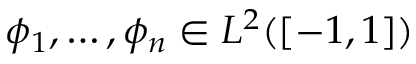Convert formula to latex. <formula><loc_0><loc_0><loc_500><loc_500>\phi _ { 1 } , \dots , \phi _ { n } \in L ^ { 2 } ( [ - 1 , 1 ] )</formula> 